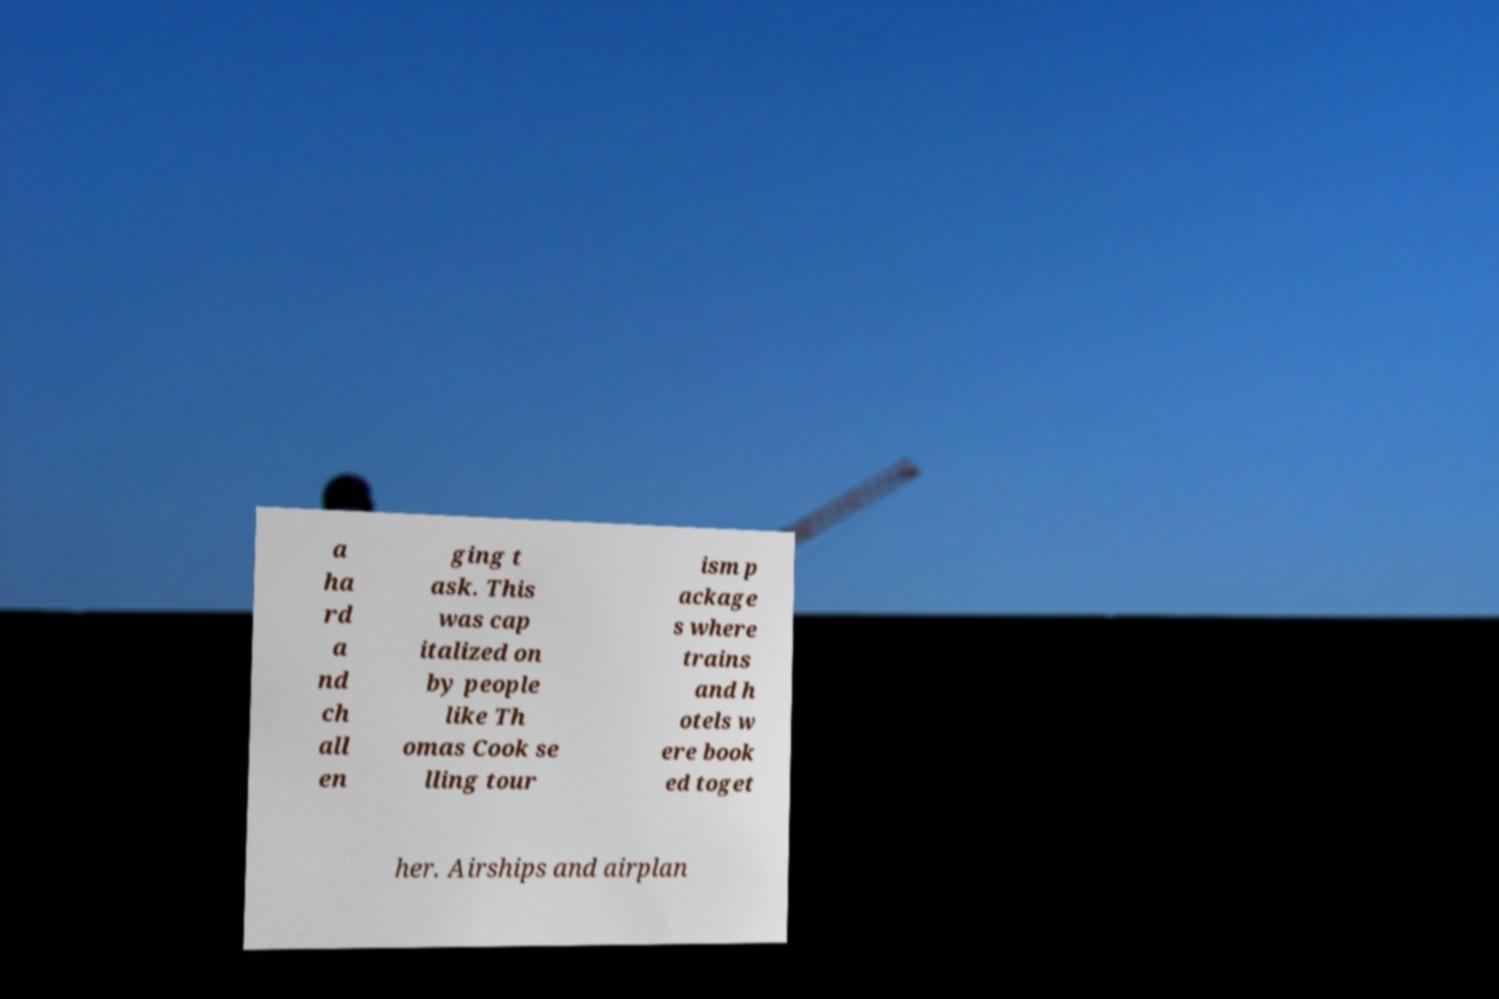Can you read and provide the text displayed in the image?This photo seems to have some interesting text. Can you extract and type it out for me? a ha rd a nd ch all en ging t ask. This was cap italized on by people like Th omas Cook se lling tour ism p ackage s where trains and h otels w ere book ed toget her. Airships and airplan 